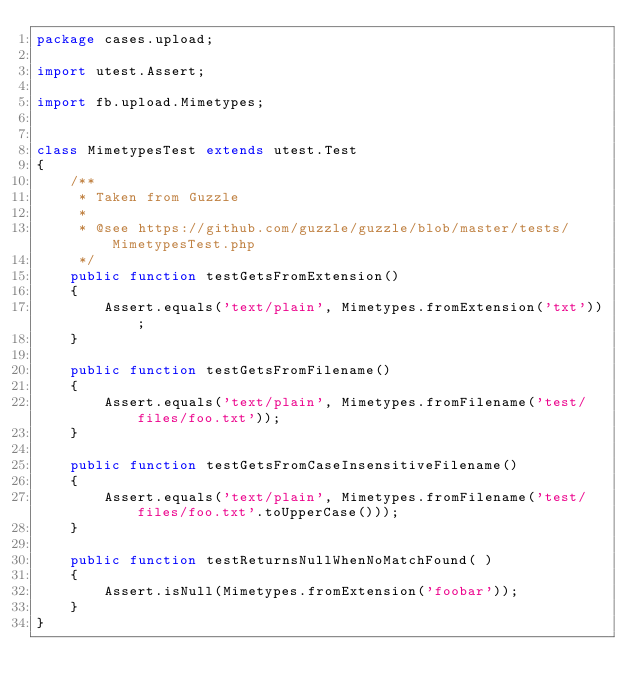Convert code to text. <code><loc_0><loc_0><loc_500><loc_500><_Haxe_>package cases.upload;

import utest.Assert;

import fb.upload.Mimetypes;


class MimetypesTest extends utest.Test
{
    /**
     * Taken from Guzzle
     *
     * @see https://github.com/guzzle/guzzle/blob/master/tests/MimetypesTest.php
     */
    public function testGetsFromExtension()
    {
        Assert.equals('text/plain', Mimetypes.fromExtension('txt'));
    }

    public function testGetsFromFilename()
    {
        Assert.equals('text/plain', Mimetypes.fromFilename('test/files/foo.txt'));
    }

    public function testGetsFromCaseInsensitiveFilename()
    {
        Assert.equals('text/plain', Mimetypes.fromFilename('test/files/foo.txt'.toUpperCase()));
    }

    public function testReturnsNullWhenNoMatchFound( )
    {
        Assert.isNull(Mimetypes.fromExtension('foobar'));
    }
}</code> 